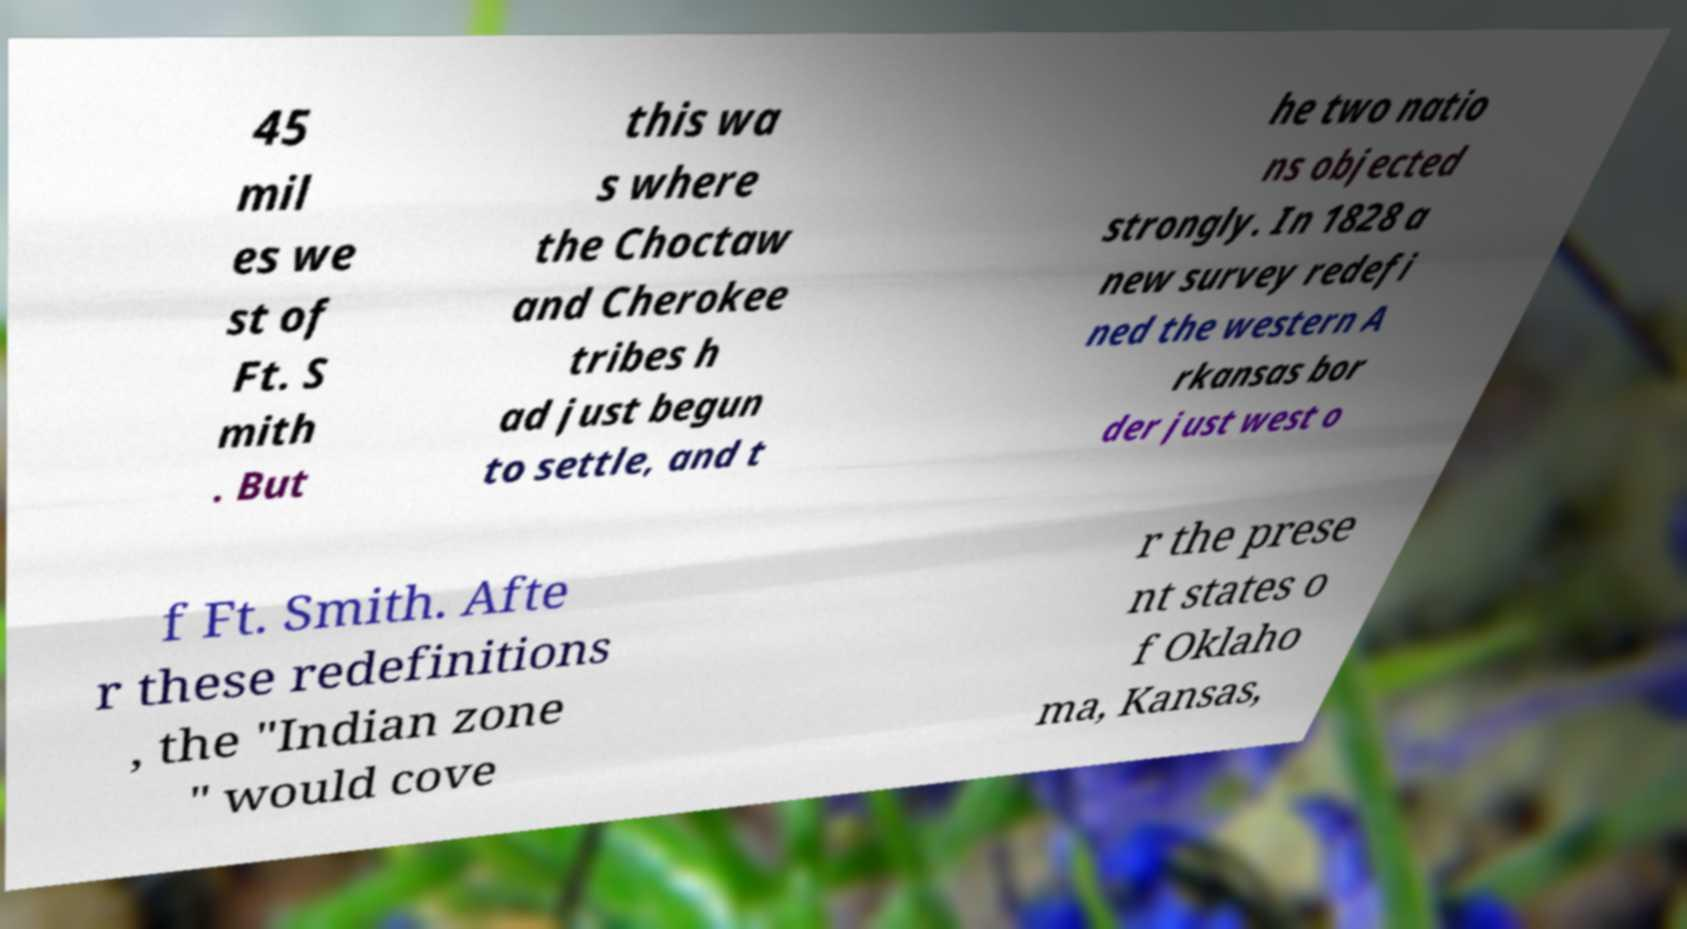Please identify and transcribe the text found in this image. 45 mil es we st of Ft. S mith . But this wa s where the Choctaw and Cherokee tribes h ad just begun to settle, and t he two natio ns objected strongly. In 1828 a new survey redefi ned the western A rkansas bor der just west o f Ft. Smith. Afte r these redefinitions , the "Indian zone " would cove r the prese nt states o f Oklaho ma, Kansas, 